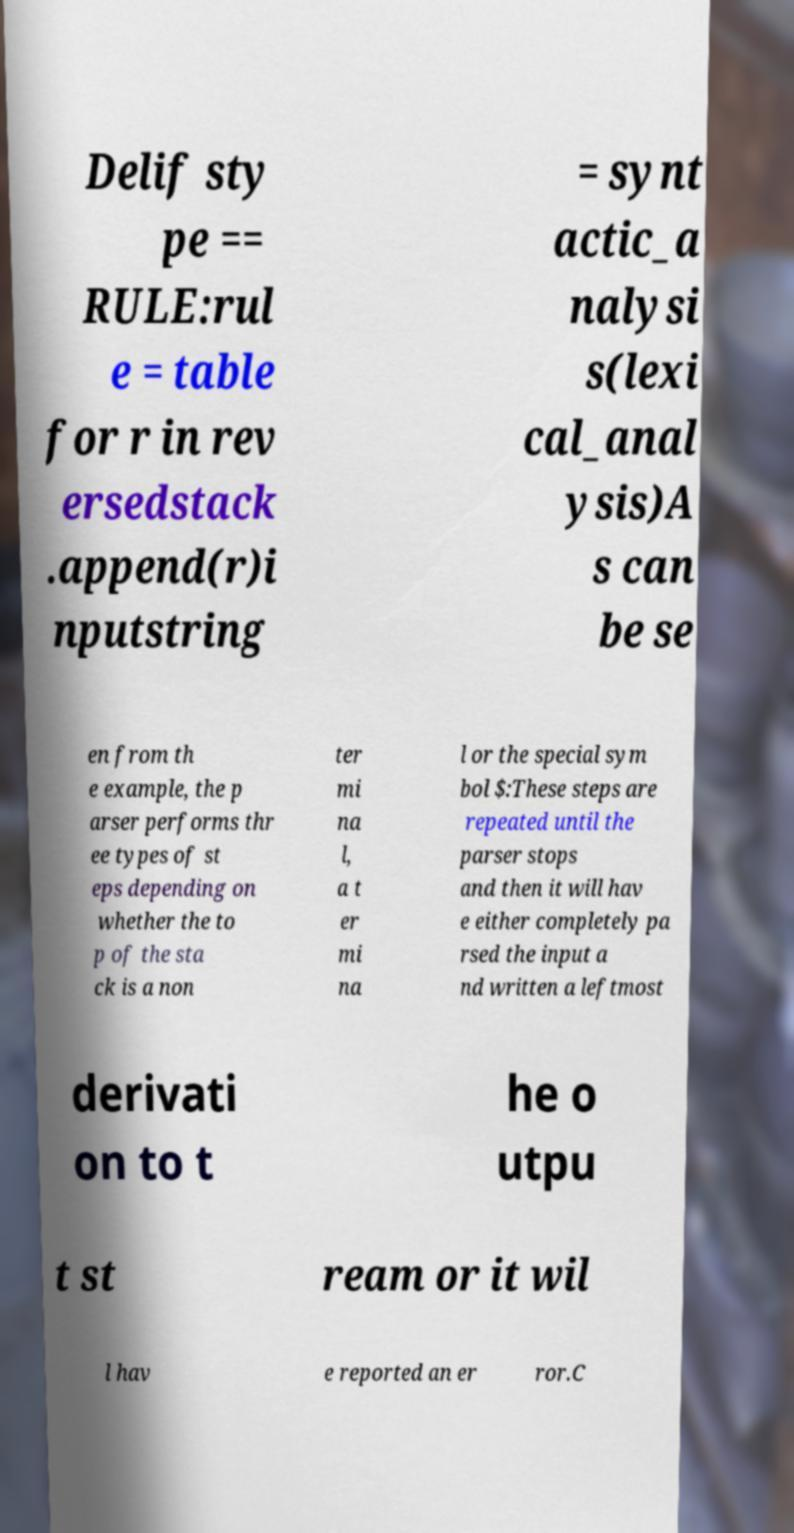For documentation purposes, I need the text within this image transcribed. Could you provide that? Delif sty pe == RULE:rul e = table for r in rev ersedstack .append(r)i nputstring = synt actic_a nalysi s(lexi cal_anal ysis)A s can be se en from th e example, the p arser performs thr ee types of st eps depending on whether the to p of the sta ck is a non ter mi na l, a t er mi na l or the special sym bol $:These steps are repeated until the parser stops and then it will hav e either completely pa rsed the input a nd written a leftmost derivati on to t he o utpu t st ream or it wil l hav e reported an er ror.C 